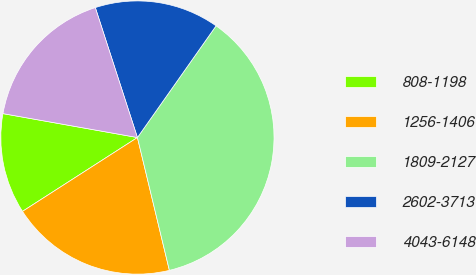<chart> <loc_0><loc_0><loc_500><loc_500><pie_chart><fcel>808-1198<fcel>1256-1406<fcel>1809-2127<fcel>2602-3713<fcel>4043-6148<nl><fcel>11.89%<fcel>19.67%<fcel>36.48%<fcel>14.75%<fcel>17.21%<nl></chart> 